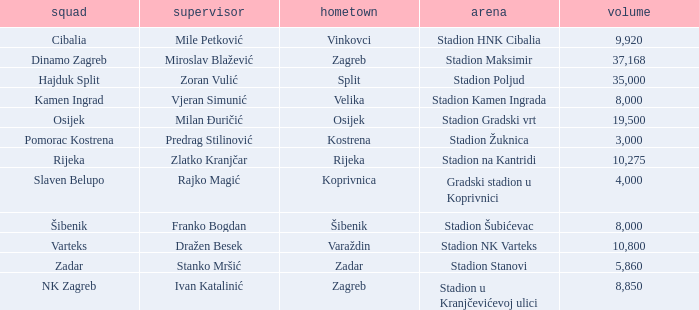What team has a home city of Velika? Kamen Ingrad. 